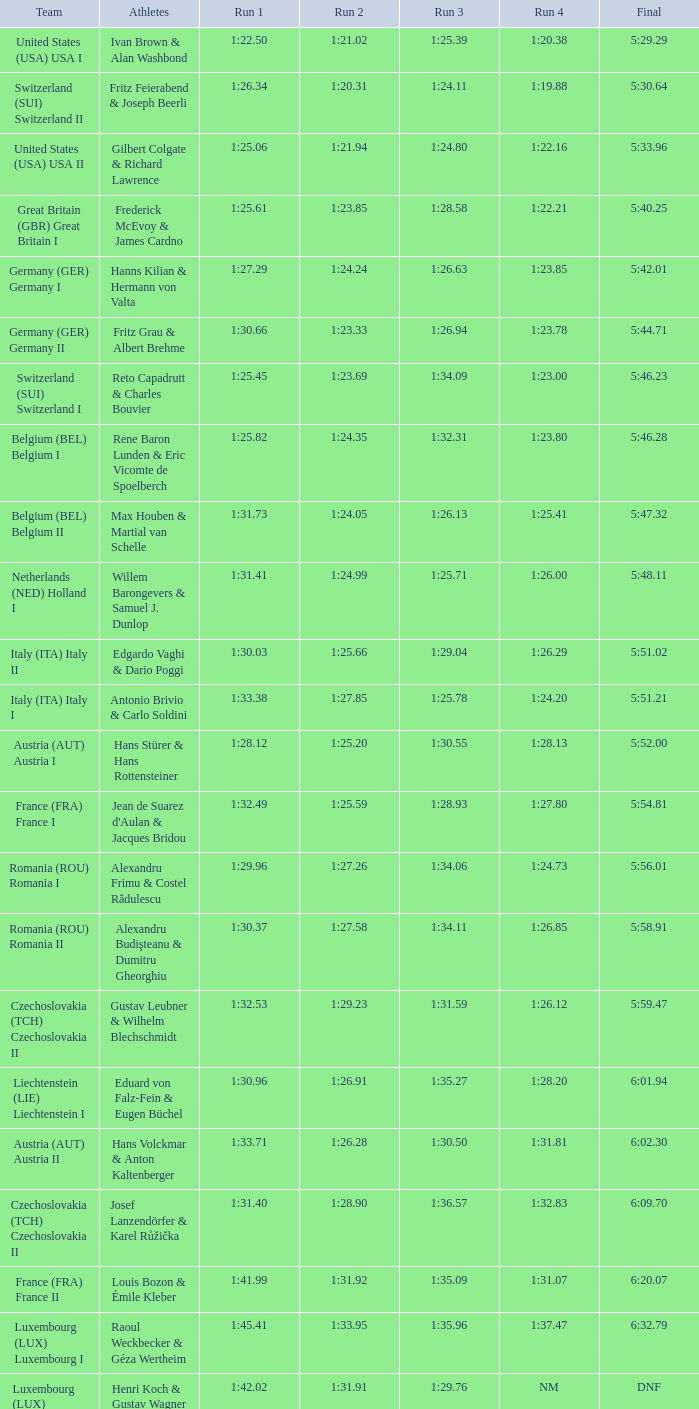Which run 2 has a run 1 time of 1:3 1:25.66. 